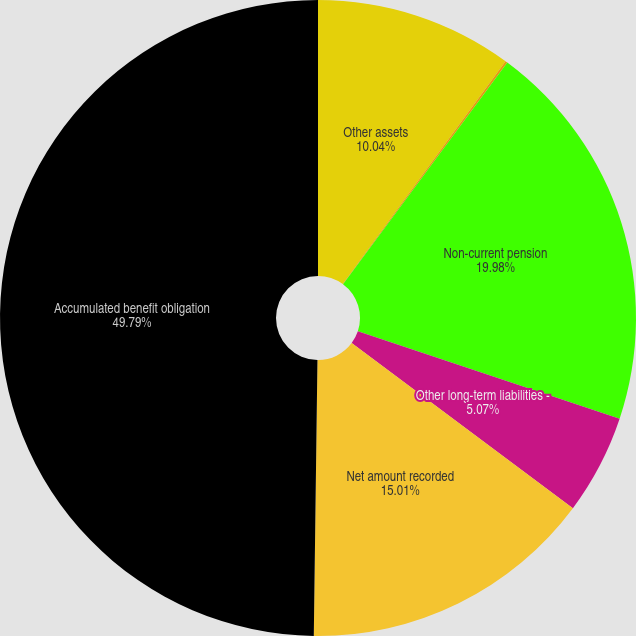Convert chart to OTSL. <chart><loc_0><loc_0><loc_500><loc_500><pie_chart><fcel>Other assets<fcel>Accrued expenses and other<fcel>Non-current pension<fcel>Other long-term liabilities -<fcel>Net amount recorded<fcel>Accumulated benefit obligation<nl><fcel>10.04%<fcel>0.11%<fcel>19.98%<fcel>5.07%<fcel>15.01%<fcel>49.79%<nl></chart> 